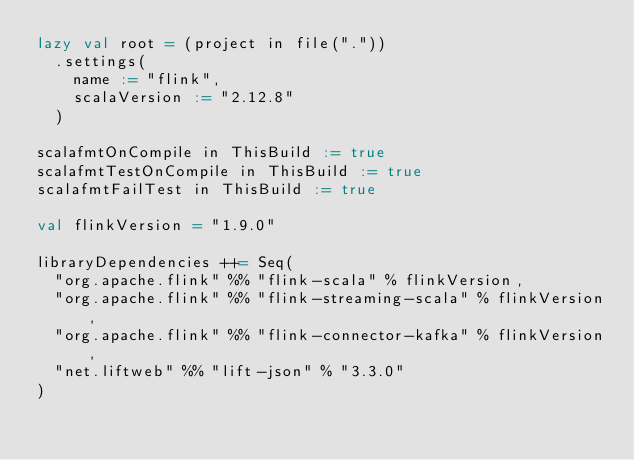Convert code to text. <code><loc_0><loc_0><loc_500><loc_500><_Scala_>lazy val root = (project in file("."))
  .settings(
    name := "flink",
    scalaVersion := "2.12.8"
  )

scalafmtOnCompile in ThisBuild := true
scalafmtTestOnCompile in ThisBuild := true
scalafmtFailTest in ThisBuild := true

val flinkVersion = "1.9.0"

libraryDependencies ++= Seq(
  "org.apache.flink" %% "flink-scala" % flinkVersion,
  "org.apache.flink" %% "flink-streaming-scala" % flinkVersion,
  "org.apache.flink" %% "flink-connector-kafka" % flinkVersion,
  "net.liftweb" %% "lift-json" % "3.3.0"
)
</code> 